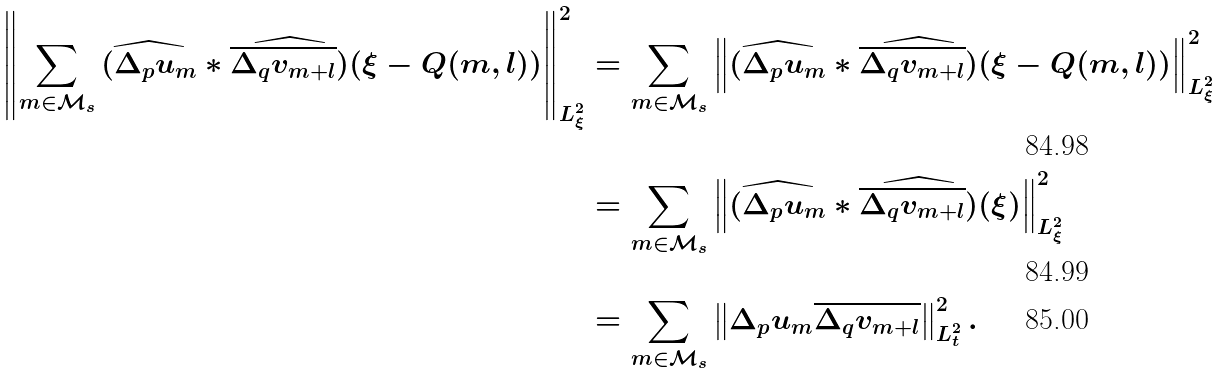<formula> <loc_0><loc_0><loc_500><loc_500>\left \| \sum _ { m \in \mathcal { M } _ { s } } \widehat { ( \Delta _ { p } u _ { m } } * \widehat { \overline { \Delta _ { q } v _ { m + l } } ) } ( \xi - Q ( m , l ) ) \right \| _ { L _ { \xi } ^ { 2 } } ^ { 2 } & = \sum _ { m \in \mathcal { M } _ { s } } \left \| \widehat { ( \Delta _ { p } u _ { m } } * \widehat { \overline { \Delta _ { q } v _ { m + l } } ) } ( \xi - Q ( m , l ) ) \right \| _ { L _ { \xi } ^ { 2 } } ^ { 2 } \\ & = \sum _ { m \in \mathcal { M } _ { s } } \left \| \widehat { ( \Delta _ { p } u _ { m } } * \widehat { \overline { \Delta _ { q } v _ { m + l } } ) } ( \xi ) \right \| _ { L _ { \xi } ^ { 2 } } ^ { 2 } \\ & = \sum _ { m \in \mathcal { M } _ { s } } \left \| \Delta _ { p } u _ { m } \overline { \Delta _ { q } v _ { m + l } } \right \| _ { L _ { t } ^ { 2 } } ^ { 2 } .</formula> 